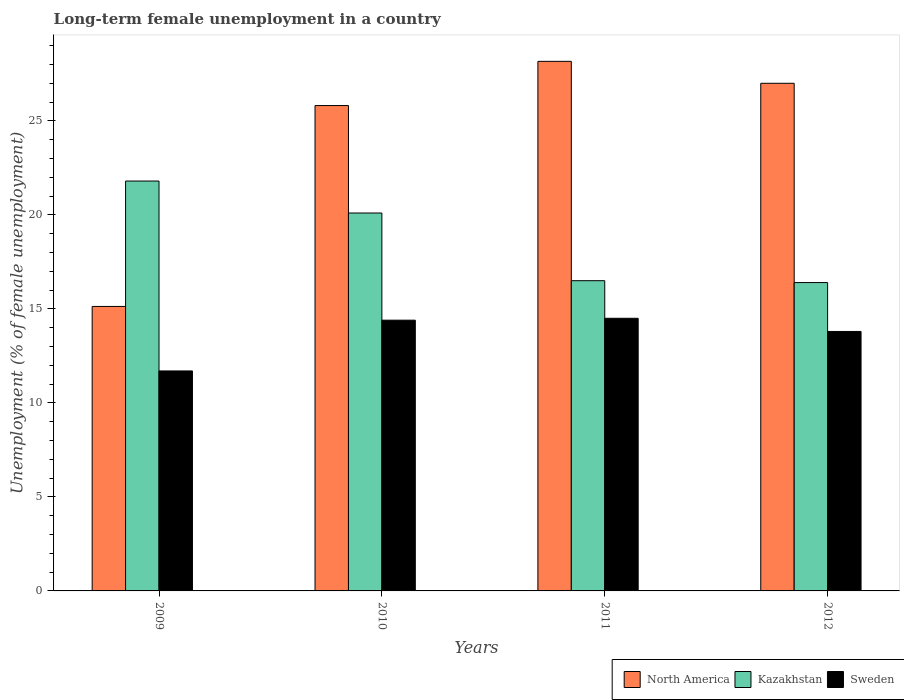How many groups of bars are there?
Your answer should be compact. 4. Are the number of bars on each tick of the X-axis equal?
Keep it short and to the point. Yes. What is the label of the 3rd group of bars from the left?
Ensure brevity in your answer.  2011. In how many cases, is the number of bars for a given year not equal to the number of legend labels?
Your response must be concise. 0. What is the percentage of long-term unemployed female population in Sweden in 2012?
Make the answer very short. 13.8. Across all years, what is the minimum percentage of long-term unemployed female population in North America?
Give a very brief answer. 15.13. In which year was the percentage of long-term unemployed female population in Sweden maximum?
Offer a terse response. 2011. What is the total percentage of long-term unemployed female population in North America in the graph?
Provide a short and direct response. 96.11. What is the difference between the percentage of long-term unemployed female population in Sweden in 2009 and that in 2012?
Provide a short and direct response. -2.1. What is the difference between the percentage of long-term unemployed female population in North America in 2011 and the percentage of long-term unemployed female population in Kazakhstan in 2010?
Keep it short and to the point. 8.07. What is the average percentage of long-term unemployed female population in Kazakhstan per year?
Your answer should be very brief. 18.7. In the year 2011, what is the difference between the percentage of long-term unemployed female population in North America and percentage of long-term unemployed female population in Kazakhstan?
Make the answer very short. 11.67. In how many years, is the percentage of long-term unemployed female population in Kazakhstan greater than 10 %?
Offer a terse response. 4. What is the ratio of the percentage of long-term unemployed female population in Sweden in 2010 to that in 2011?
Keep it short and to the point. 0.99. What is the difference between the highest and the second highest percentage of long-term unemployed female population in North America?
Offer a terse response. 1.17. What is the difference between the highest and the lowest percentage of long-term unemployed female population in Sweden?
Make the answer very short. 2.8. In how many years, is the percentage of long-term unemployed female population in Sweden greater than the average percentage of long-term unemployed female population in Sweden taken over all years?
Your answer should be very brief. 3. What does the 3rd bar from the left in 2012 represents?
Make the answer very short. Sweden. How many bars are there?
Make the answer very short. 12. What is the difference between two consecutive major ticks on the Y-axis?
Your response must be concise. 5. How many legend labels are there?
Offer a terse response. 3. How are the legend labels stacked?
Your answer should be compact. Horizontal. What is the title of the graph?
Offer a very short reply. Long-term female unemployment in a country. Does "Bosnia and Herzegovina" appear as one of the legend labels in the graph?
Ensure brevity in your answer.  No. What is the label or title of the Y-axis?
Offer a terse response. Unemployment (% of female unemployment). What is the Unemployment (% of female unemployment) of North America in 2009?
Make the answer very short. 15.13. What is the Unemployment (% of female unemployment) of Kazakhstan in 2009?
Your answer should be compact. 21.8. What is the Unemployment (% of female unemployment) in Sweden in 2009?
Your response must be concise. 11.7. What is the Unemployment (% of female unemployment) of North America in 2010?
Your answer should be very brief. 25.81. What is the Unemployment (% of female unemployment) of Kazakhstan in 2010?
Keep it short and to the point. 20.1. What is the Unemployment (% of female unemployment) of Sweden in 2010?
Your answer should be very brief. 14.4. What is the Unemployment (% of female unemployment) in North America in 2011?
Give a very brief answer. 28.17. What is the Unemployment (% of female unemployment) in Kazakhstan in 2011?
Keep it short and to the point. 16.5. What is the Unemployment (% of female unemployment) in North America in 2012?
Your answer should be very brief. 27. What is the Unemployment (% of female unemployment) in Kazakhstan in 2012?
Your response must be concise. 16.4. What is the Unemployment (% of female unemployment) of Sweden in 2012?
Keep it short and to the point. 13.8. Across all years, what is the maximum Unemployment (% of female unemployment) of North America?
Provide a short and direct response. 28.17. Across all years, what is the maximum Unemployment (% of female unemployment) in Kazakhstan?
Make the answer very short. 21.8. Across all years, what is the minimum Unemployment (% of female unemployment) of North America?
Your answer should be compact. 15.13. Across all years, what is the minimum Unemployment (% of female unemployment) in Kazakhstan?
Offer a very short reply. 16.4. Across all years, what is the minimum Unemployment (% of female unemployment) in Sweden?
Your response must be concise. 11.7. What is the total Unemployment (% of female unemployment) of North America in the graph?
Your response must be concise. 96.11. What is the total Unemployment (% of female unemployment) in Kazakhstan in the graph?
Your response must be concise. 74.8. What is the total Unemployment (% of female unemployment) of Sweden in the graph?
Ensure brevity in your answer.  54.4. What is the difference between the Unemployment (% of female unemployment) in North America in 2009 and that in 2010?
Your answer should be compact. -10.69. What is the difference between the Unemployment (% of female unemployment) of Kazakhstan in 2009 and that in 2010?
Your answer should be compact. 1.7. What is the difference between the Unemployment (% of female unemployment) of North America in 2009 and that in 2011?
Provide a short and direct response. -13.04. What is the difference between the Unemployment (% of female unemployment) in Kazakhstan in 2009 and that in 2011?
Provide a succinct answer. 5.3. What is the difference between the Unemployment (% of female unemployment) in North America in 2009 and that in 2012?
Your response must be concise. -11.87. What is the difference between the Unemployment (% of female unemployment) in North America in 2010 and that in 2011?
Your answer should be compact. -2.35. What is the difference between the Unemployment (% of female unemployment) of Kazakhstan in 2010 and that in 2011?
Provide a short and direct response. 3.6. What is the difference between the Unemployment (% of female unemployment) in North America in 2010 and that in 2012?
Provide a succinct answer. -1.18. What is the difference between the Unemployment (% of female unemployment) in North America in 2011 and that in 2012?
Ensure brevity in your answer.  1.17. What is the difference between the Unemployment (% of female unemployment) in Sweden in 2011 and that in 2012?
Offer a very short reply. 0.7. What is the difference between the Unemployment (% of female unemployment) in North America in 2009 and the Unemployment (% of female unemployment) in Kazakhstan in 2010?
Ensure brevity in your answer.  -4.97. What is the difference between the Unemployment (% of female unemployment) of North America in 2009 and the Unemployment (% of female unemployment) of Sweden in 2010?
Give a very brief answer. 0.73. What is the difference between the Unemployment (% of female unemployment) of North America in 2009 and the Unemployment (% of female unemployment) of Kazakhstan in 2011?
Provide a short and direct response. -1.37. What is the difference between the Unemployment (% of female unemployment) in North America in 2009 and the Unemployment (% of female unemployment) in Sweden in 2011?
Provide a succinct answer. 0.63. What is the difference between the Unemployment (% of female unemployment) of Kazakhstan in 2009 and the Unemployment (% of female unemployment) of Sweden in 2011?
Offer a terse response. 7.3. What is the difference between the Unemployment (% of female unemployment) in North America in 2009 and the Unemployment (% of female unemployment) in Kazakhstan in 2012?
Offer a terse response. -1.27. What is the difference between the Unemployment (% of female unemployment) in North America in 2009 and the Unemployment (% of female unemployment) in Sweden in 2012?
Provide a short and direct response. 1.33. What is the difference between the Unemployment (% of female unemployment) in North America in 2010 and the Unemployment (% of female unemployment) in Kazakhstan in 2011?
Offer a terse response. 9.31. What is the difference between the Unemployment (% of female unemployment) of North America in 2010 and the Unemployment (% of female unemployment) of Sweden in 2011?
Offer a terse response. 11.31. What is the difference between the Unemployment (% of female unemployment) in North America in 2010 and the Unemployment (% of female unemployment) in Kazakhstan in 2012?
Your answer should be very brief. 9.41. What is the difference between the Unemployment (% of female unemployment) of North America in 2010 and the Unemployment (% of female unemployment) of Sweden in 2012?
Make the answer very short. 12.01. What is the difference between the Unemployment (% of female unemployment) of North America in 2011 and the Unemployment (% of female unemployment) of Kazakhstan in 2012?
Your response must be concise. 11.77. What is the difference between the Unemployment (% of female unemployment) in North America in 2011 and the Unemployment (% of female unemployment) in Sweden in 2012?
Your response must be concise. 14.37. What is the average Unemployment (% of female unemployment) in North America per year?
Offer a very short reply. 24.03. In the year 2009, what is the difference between the Unemployment (% of female unemployment) in North America and Unemployment (% of female unemployment) in Kazakhstan?
Ensure brevity in your answer.  -6.67. In the year 2009, what is the difference between the Unemployment (% of female unemployment) of North America and Unemployment (% of female unemployment) of Sweden?
Your response must be concise. 3.43. In the year 2009, what is the difference between the Unemployment (% of female unemployment) of Kazakhstan and Unemployment (% of female unemployment) of Sweden?
Provide a short and direct response. 10.1. In the year 2010, what is the difference between the Unemployment (% of female unemployment) in North America and Unemployment (% of female unemployment) in Kazakhstan?
Give a very brief answer. 5.71. In the year 2010, what is the difference between the Unemployment (% of female unemployment) of North America and Unemployment (% of female unemployment) of Sweden?
Keep it short and to the point. 11.41. In the year 2011, what is the difference between the Unemployment (% of female unemployment) in North America and Unemployment (% of female unemployment) in Kazakhstan?
Your answer should be compact. 11.67. In the year 2011, what is the difference between the Unemployment (% of female unemployment) in North America and Unemployment (% of female unemployment) in Sweden?
Give a very brief answer. 13.67. In the year 2011, what is the difference between the Unemployment (% of female unemployment) in Kazakhstan and Unemployment (% of female unemployment) in Sweden?
Make the answer very short. 2. In the year 2012, what is the difference between the Unemployment (% of female unemployment) of North America and Unemployment (% of female unemployment) of Kazakhstan?
Make the answer very short. 10.6. In the year 2012, what is the difference between the Unemployment (% of female unemployment) in North America and Unemployment (% of female unemployment) in Sweden?
Your answer should be compact. 13.2. In the year 2012, what is the difference between the Unemployment (% of female unemployment) in Kazakhstan and Unemployment (% of female unemployment) in Sweden?
Your answer should be very brief. 2.6. What is the ratio of the Unemployment (% of female unemployment) in North America in 2009 to that in 2010?
Provide a short and direct response. 0.59. What is the ratio of the Unemployment (% of female unemployment) of Kazakhstan in 2009 to that in 2010?
Your response must be concise. 1.08. What is the ratio of the Unemployment (% of female unemployment) in Sweden in 2009 to that in 2010?
Provide a succinct answer. 0.81. What is the ratio of the Unemployment (% of female unemployment) of North America in 2009 to that in 2011?
Make the answer very short. 0.54. What is the ratio of the Unemployment (% of female unemployment) in Kazakhstan in 2009 to that in 2011?
Give a very brief answer. 1.32. What is the ratio of the Unemployment (% of female unemployment) in Sweden in 2009 to that in 2011?
Your response must be concise. 0.81. What is the ratio of the Unemployment (% of female unemployment) of North America in 2009 to that in 2012?
Give a very brief answer. 0.56. What is the ratio of the Unemployment (% of female unemployment) in Kazakhstan in 2009 to that in 2012?
Keep it short and to the point. 1.33. What is the ratio of the Unemployment (% of female unemployment) of Sweden in 2009 to that in 2012?
Ensure brevity in your answer.  0.85. What is the ratio of the Unemployment (% of female unemployment) in North America in 2010 to that in 2011?
Provide a succinct answer. 0.92. What is the ratio of the Unemployment (% of female unemployment) in Kazakhstan in 2010 to that in 2011?
Ensure brevity in your answer.  1.22. What is the ratio of the Unemployment (% of female unemployment) in Sweden in 2010 to that in 2011?
Ensure brevity in your answer.  0.99. What is the ratio of the Unemployment (% of female unemployment) in North America in 2010 to that in 2012?
Offer a terse response. 0.96. What is the ratio of the Unemployment (% of female unemployment) in Kazakhstan in 2010 to that in 2012?
Offer a terse response. 1.23. What is the ratio of the Unemployment (% of female unemployment) of Sweden in 2010 to that in 2012?
Offer a very short reply. 1.04. What is the ratio of the Unemployment (% of female unemployment) in North America in 2011 to that in 2012?
Make the answer very short. 1.04. What is the ratio of the Unemployment (% of female unemployment) in Sweden in 2011 to that in 2012?
Offer a very short reply. 1.05. What is the difference between the highest and the second highest Unemployment (% of female unemployment) in North America?
Offer a terse response. 1.17. What is the difference between the highest and the lowest Unemployment (% of female unemployment) in North America?
Provide a succinct answer. 13.04. What is the difference between the highest and the lowest Unemployment (% of female unemployment) in Sweden?
Keep it short and to the point. 2.8. 